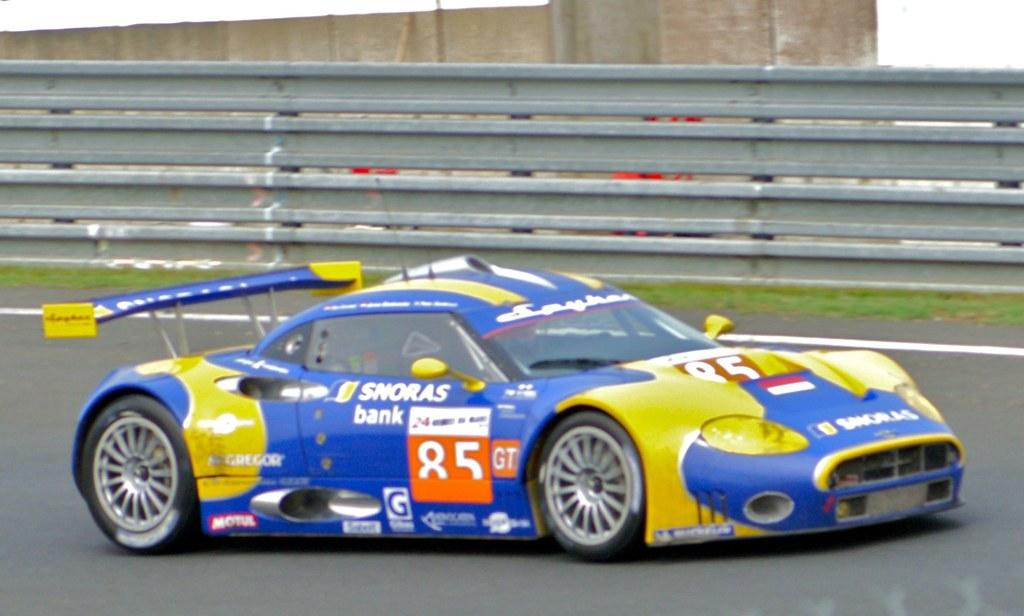What is the main subject of the image? There is a vehicle on the road in the image. What can be seen in the background of the image? There is a fence and grass in the background of the image. Are there any other objects visible in the background? Yes, there are some objects visible in the background of the image. What type of behavior can be observed in the vehicle's owner in the image? There is no information about the vehicle's owner in the image, so we cannot comment on their behavior. What type of stem is visible in the image? There is no stem present in the image. 